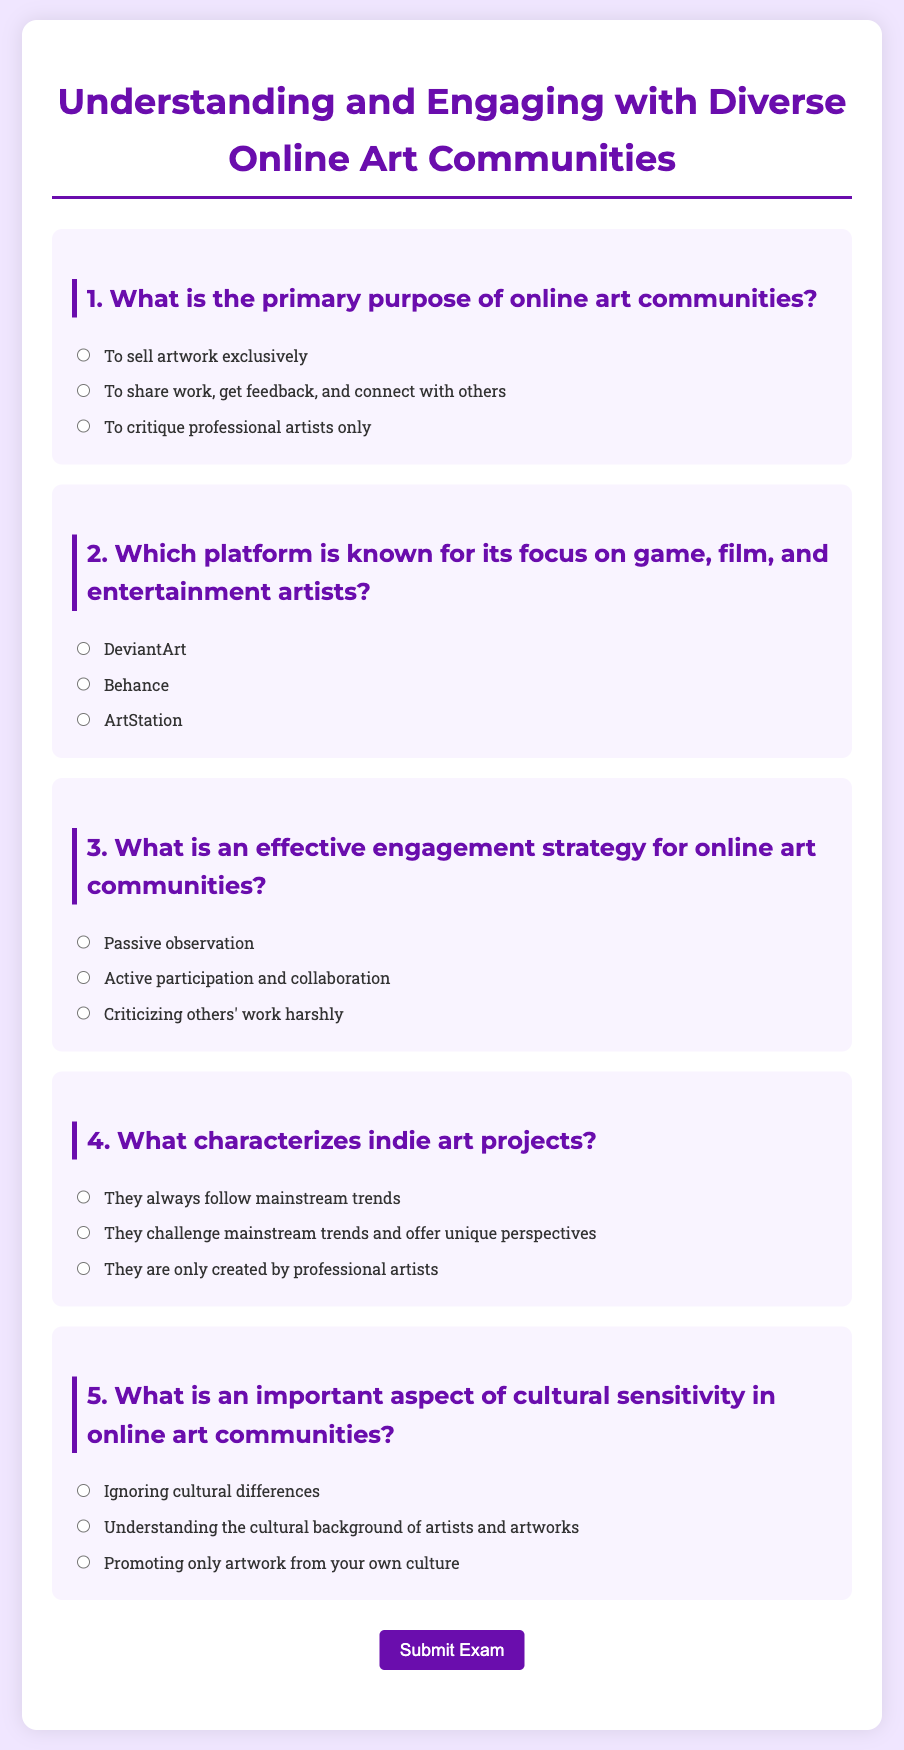What is the title of the exam? The title can be found at the top of the document, presented prominently.
Answer: Understanding and Engaging with Diverse Online Art Communities How many questions are in the exam? By counting the sections labeled "question," we determine the total number of questions present.
Answer: 5 What is the option labeled for question 3 regarding engagement strategies? The option for question 3 describes a beneficial approach to participating in communities.
Answer: Active participation and collaboration Which platform is mentioned for game and entertainment artists? The document specifically lists the platform focused on professionals in game and entertainment sectors.
Answer: ArtStation What is the correct answer to question 4 about indie art projects? The explanation of indie art projects is found in question 4 options provided in the document.
Answer: They challenge mainstream trends and offer unique perspectives What aspect of cultural sensitivity is highlighted in question 5? The document emphasizes a specific understanding necessary for sensitivity in art communities.
Answer: Understanding the cultural background of artists and artworks 